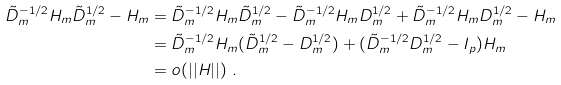<formula> <loc_0><loc_0><loc_500><loc_500>\tilde { D } _ { m } ^ { - 1 / 2 } H _ { m } \tilde { D } _ { m } ^ { 1 / 2 } - H _ { m } & = \tilde { D } _ { m } ^ { - 1 / 2 } H _ { m } \tilde { D } _ { m } ^ { 1 / 2 } - \tilde { D } _ { m } ^ { - 1 / 2 } H _ { m } { D } _ { m } ^ { 1 / 2 } + \tilde { D } _ { m } ^ { - 1 / 2 } H _ { m } { D } _ { m } ^ { 1 / 2 } - H _ { m } \\ & = \tilde { D } _ { m } ^ { - 1 / 2 } H _ { m } ( \tilde { D } _ { m } ^ { 1 / 2 } - D _ { m } ^ { 1 / 2 } ) + ( \tilde { D } _ { m } ^ { - 1 / 2 } D _ { m } ^ { 1 / 2 } - I _ { p } ) H _ { m } \\ & = o ( | | H | | ) \ .</formula> 